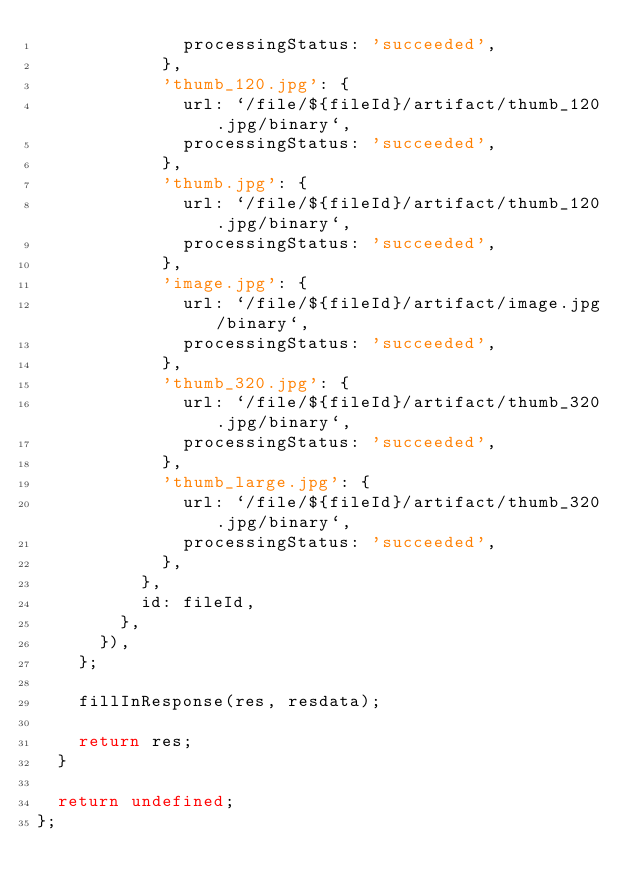Convert code to text. <code><loc_0><loc_0><loc_500><loc_500><_TypeScript_>              processingStatus: 'succeeded',
            },
            'thumb_120.jpg': {
              url: `/file/${fileId}/artifact/thumb_120.jpg/binary`,
              processingStatus: 'succeeded',
            },
            'thumb.jpg': {
              url: `/file/${fileId}/artifact/thumb_120.jpg/binary`,
              processingStatus: 'succeeded',
            },
            'image.jpg': {
              url: `/file/${fileId}/artifact/image.jpg/binary`,
              processingStatus: 'succeeded',
            },
            'thumb_320.jpg': {
              url: `/file/${fileId}/artifact/thumb_320.jpg/binary`,
              processingStatus: 'succeeded',
            },
            'thumb_large.jpg': {
              url: `/file/${fileId}/artifact/thumb_320.jpg/binary`,
              processingStatus: 'succeeded',
            },
          },
          id: fileId,
        },
      }),
    };

    fillInResponse(res, resdata);

    return res;
  }

  return undefined;
};
</code> 